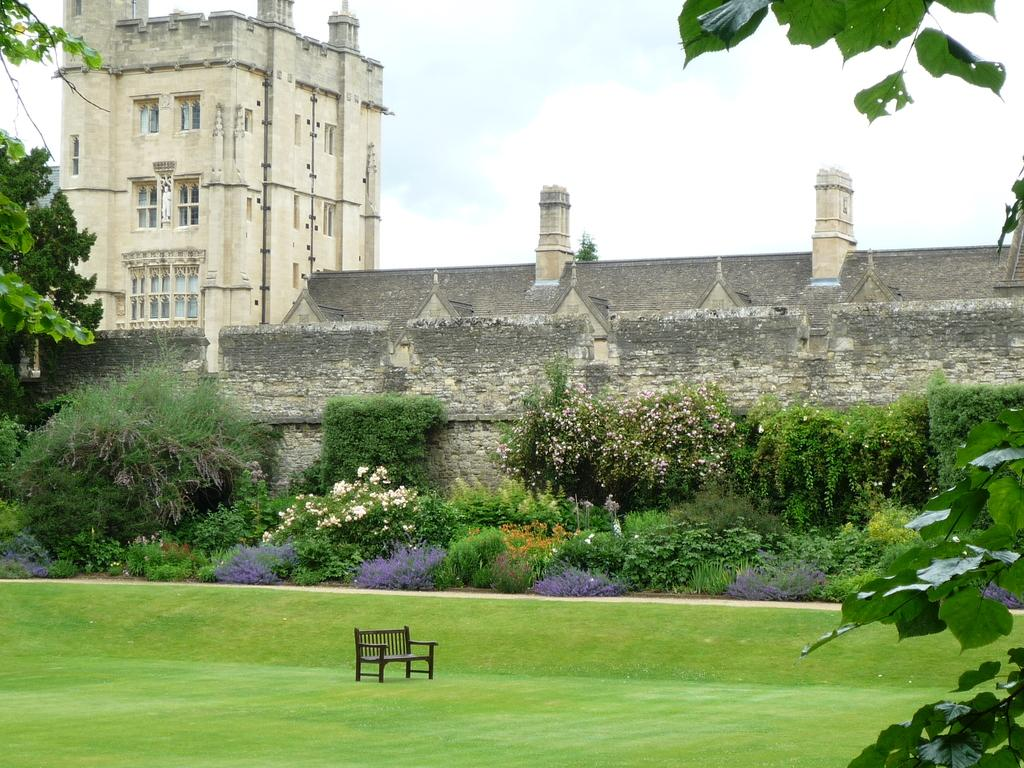What type of structure is in the image? There is a building in the image. What feature can be seen on the building? The building has windows. What type of seating is available in the image? There is a bench in the image. What type of vegetation is present in the image? Grass, plants, trees, and flower plants are visible in the image. What architectural element can be seen in the image? There is a wall in the image. What part of the natural environment is visible in the image? The sky is visible in the image. Where is the grandmother sitting with the rabbits in the image? There is no grandmother or rabbits present in the image. 